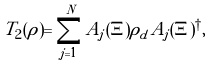<formula> <loc_0><loc_0><loc_500><loc_500>T _ { 2 } ( \rho ) = \sum _ { j = 1 } ^ { N } A _ { j } ( \Xi ) \rho _ { d } A _ { j } ( \Xi ) ^ { \dagger } ,</formula> 